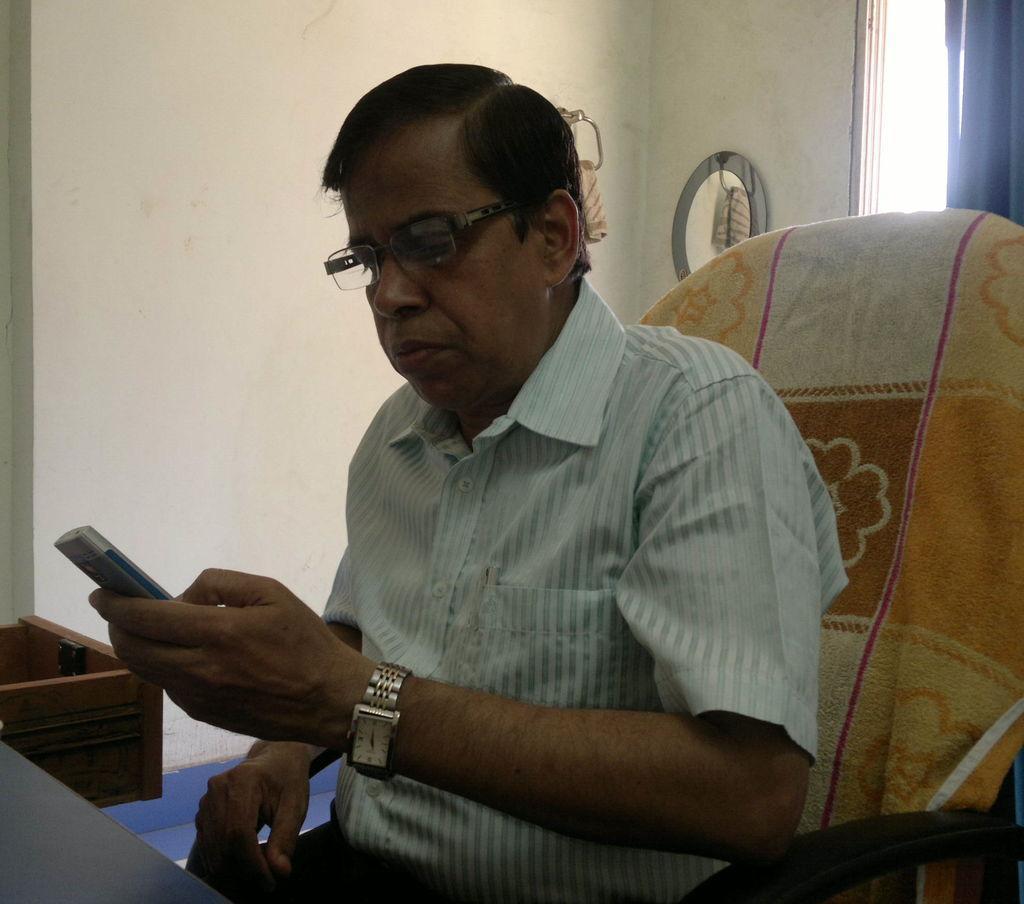Please provide a concise description of this image. In this image we can see a man is sitting on the chair. He is wearing shirt, watch and holding mobile in his hand. In front of the man, we can see the table. We can see mirror on the wall and one window with blue curtain in the background. There is a towel on the chair. 